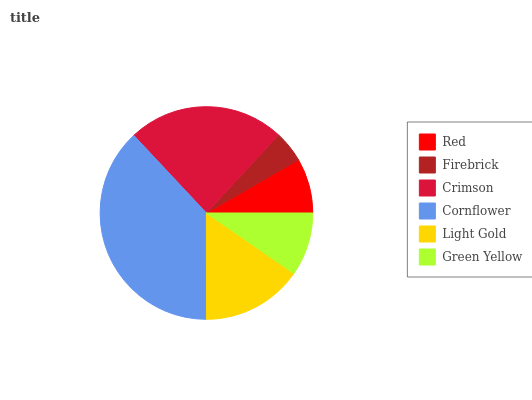Is Firebrick the minimum?
Answer yes or no. Yes. Is Cornflower the maximum?
Answer yes or no. Yes. Is Crimson the minimum?
Answer yes or no. No. Is Crimson the maximum?
Answer yes or no. No. Is Crimson greater than Firebrick?
Answer yes or no. Yes. Is Firebrick less than Crimson?
Answer yes or no. Yes. Is Firebrick greater than Crimson?
Answer yes or no. No. Is Crimson less than Firebrick?
Answer yes or no. No. Is Light Gold the high median?
Answer yes or no. Yes. Is Green Yellow the low median?
Answer yes or no. Yes. Is Cornflower the high median?
Answer yes or no. No. Is Cornflower the low median?
Answer yes or no. No. 